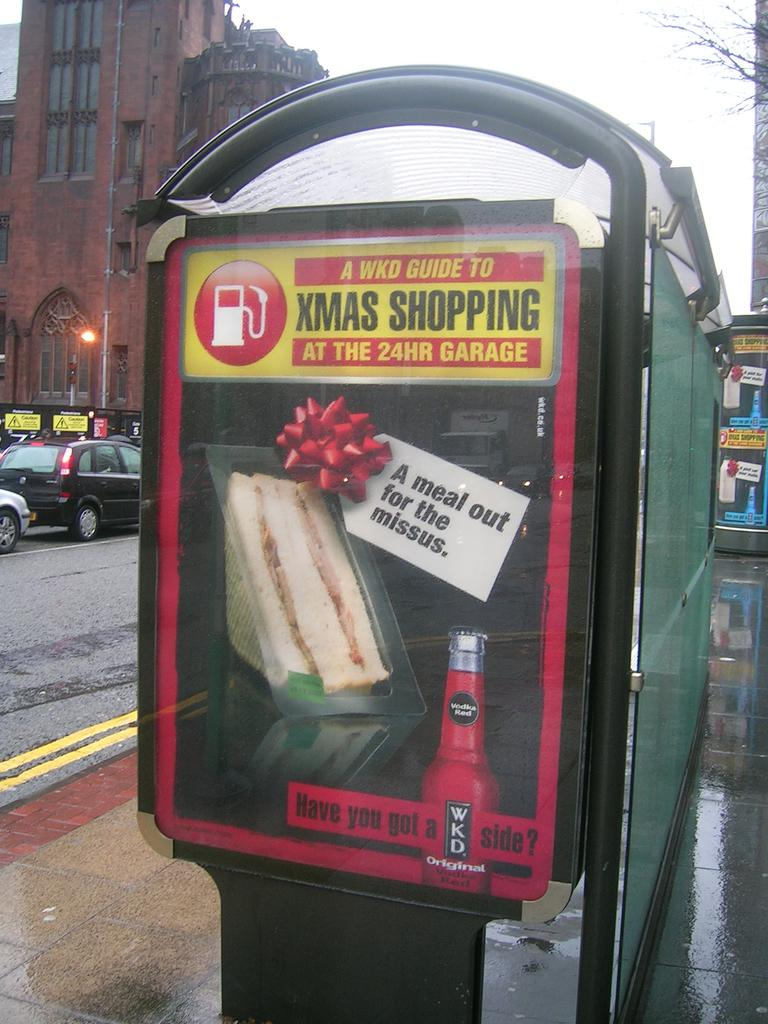What objects can be seen in the image that are made of wood or similar material? There are boards in the image. What type of transportation is visible on the road in the image? There are vehicles on the road in the image. What type of structure can be seen in the image? There is a building in the image. What type of plant is visible in the image? There is a tree in the image. What is visible in the background of the image? The sky is visible in the background of the image. Where are the chickens located in the image? There are no chickens present in the image. What type of vegetable is being used to create a painting in the image? There is no painting or vegetable, such as a yam, present in the image. 